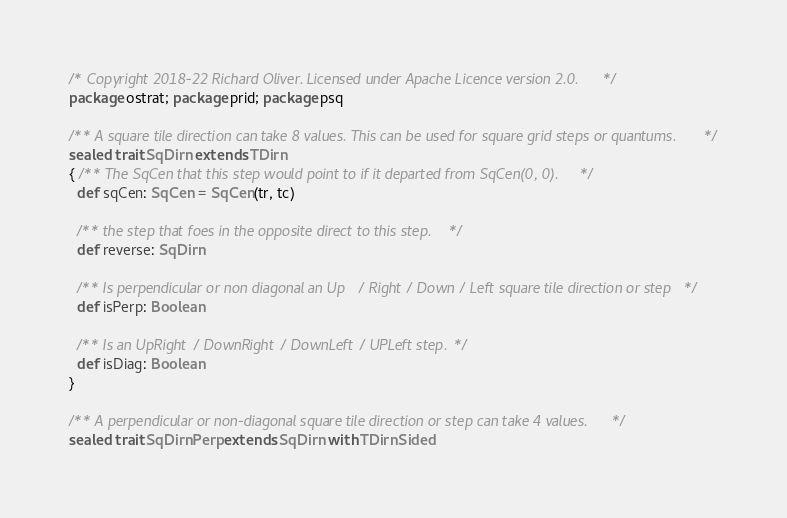<code> <loc_0><loc_0><loc_500><loc_500><_Scala_>/* Copyright 2018-22 Richard Oliver. Licensed under Apache Licence version 2.0. */
package ostrat; package prid; package psq

/** A square tile direction can take 8 values. This can be used for square grid steps or quantums. */
sealed trait SqDirn extends TDirn
{ /** The SqCen that this step would point to if it departed from SqCen(0, 0). */
  def sqCen: SqCen = SqCen(tr, tc)

  /** the step that foes in the opposite direct to this step. */
  def reverse: SqDirn

  /** Is perpendicular or non diagonal an Up / Right / Down / Left square tile direction or step */
  def isPerp: Boolean

  /** Is an UpRight / DownRight / DownLeft / UPLeft step. */
  def isDiag: Boolean
}

/** A perpendicular or non-diagonal square tile direction or step can take 4 values. */
sealed trait SqDirnPerp extends SqDirn with TDirnSided</code> 